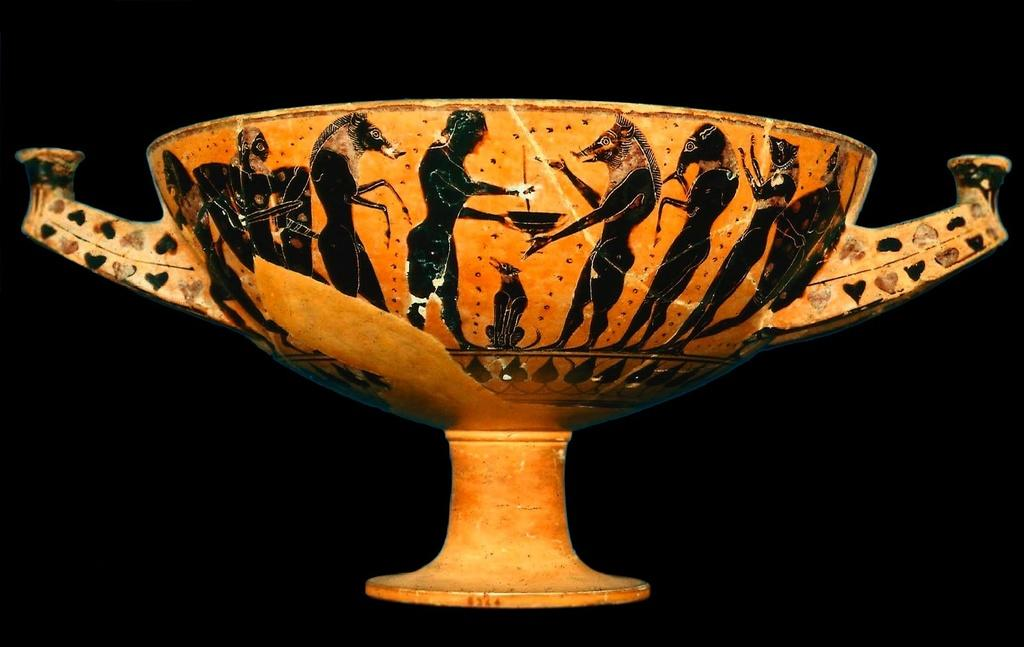What is located in the center of the image? There is a cup in the center of the image. What color is the cup? The color of the cup is not mentioned in the facts, so we cannot determine its color. What can be seen in the background of the image? The background of the image is black. How does the cup transport people in the image? The cup does not transport people in the image; it is an inanimate object. Is the cup crying in the image? The cup is an inanimate object and cannot cry in the image. 